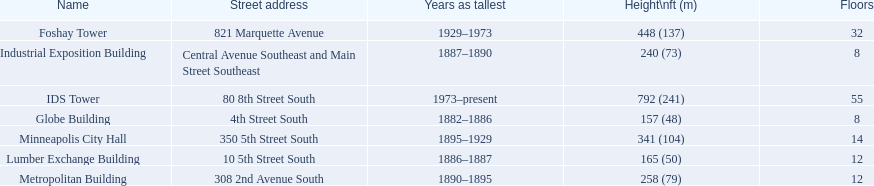How many floors does the globe building have? 8. Which building has 14 floors? Minneapolis City Hall. The lumber exchange building has the same number of floors as which building? Metropolitan Building. 